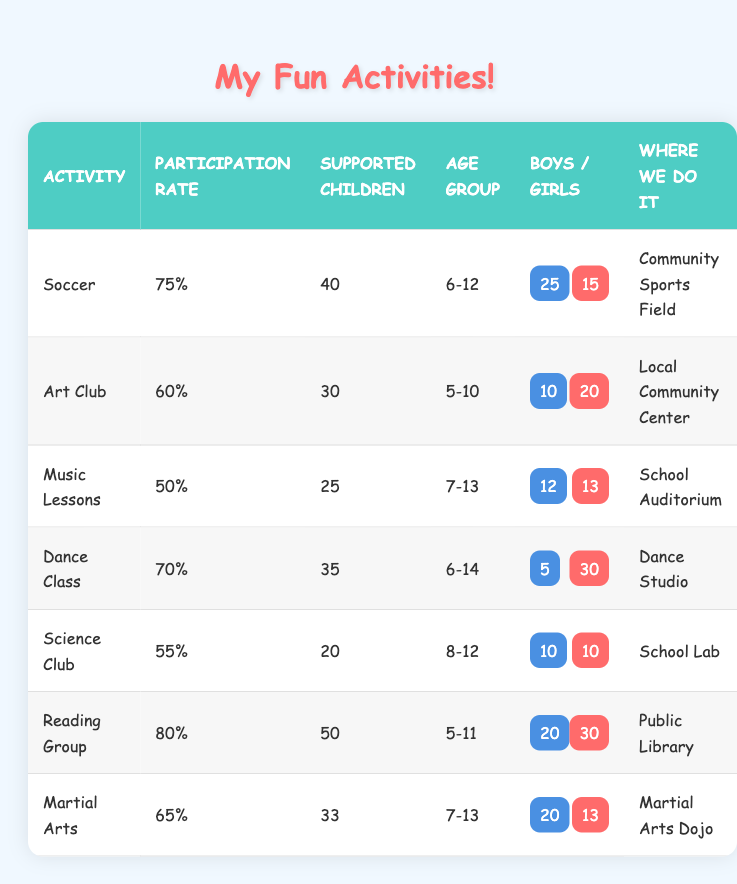What is the participation rate for the Reading Group? The Reading Group has a participation rate of 80% as shown in the table.
Answer: 80% How many supported children are there in the Dance Class? The Dance Class has 35 supported children according to the table.
Answer: 35 Which activity has the highest number of girls? The Dance Class has the highest number of girls, with 30 girls participating.
Answer: Dance Class What is the total number of supported children in Soccer and Martial Arts combined? The Soccer activity has 40 supported children and Martial Arts has 33. Adding them together gives 40 + 33 = 73.
Answer: 73 Is the participation rate for Music Lessons greater than 60%? The participation rate for Music Lessons is 50%, which is less than 60%.
Answer: No How many more boys are there than girls in the Art Club? In the Art Club, there are 10 boys and 20 girls. The difference is 20 - 10 = 10 more girls than boys.
Answer: 10 If you add the participation rates of Dance Class and Science Club, what do you get? The Dance Class has a participation rate of 70% and Science Club has 55%. Adding them gives 70 + 55 = 125%.
Answer: 125% What is the average participation rate of all activities listed in the table? The participation rates are 75%, 60%, 50%, 70%, 55%, 80%, and 65%. Summing them gives 75 + 60 + 50 + 70 + 55 + 80 + 65 = 455. There are 7 activities, so the average is 455 / 7 = 65%.
Answer: 65% What is the location for the Science Club activity? The Science Club is located in the School Lab as indicated in the table.
Answer: School Lab In the community, how many more boys are there in the Soccer activity compared to the boys in Music Lessons? The Soccer activity has 25 boys and Music Lessons has 12 boys. The difference is 25 - 12 = 13.
Answer: 13 